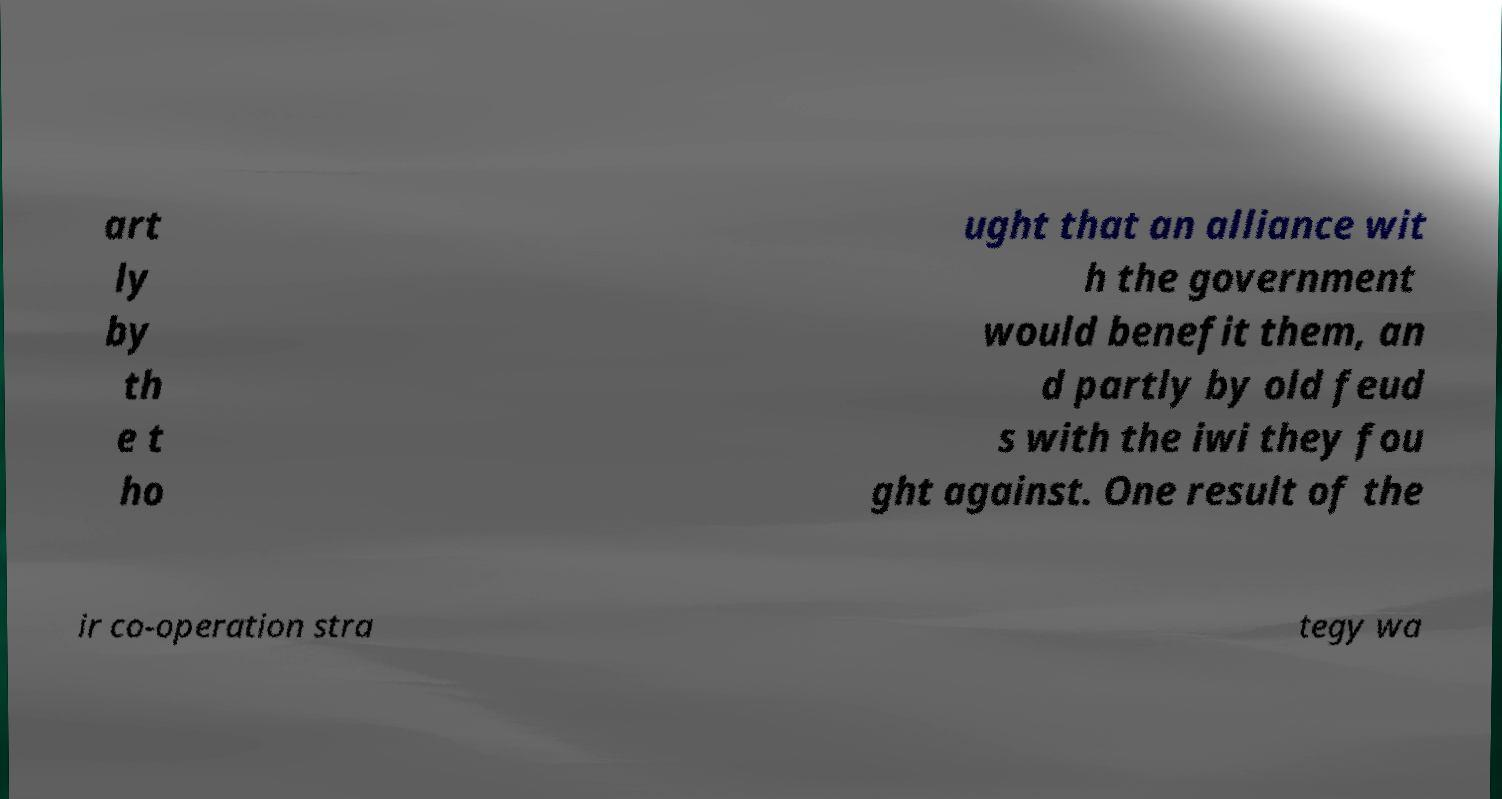Could you assist in decoding the text presented in this image and type it out clearly? art ly by th e t ho ught that an alliance wit h the government would benefit them, an d partly by old feud s with the iwi they fou ght against. One result of the ir co-operation stra tegy wa 